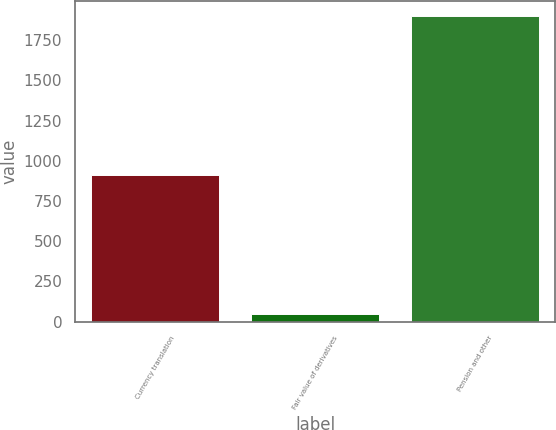Convert chart. <chart><loc_0><loc_0><loc_500><loc_500><bar_chart><fcel>Currency translation<fcel>Fair value of derivatives<fcel>Pension and other<nl><fcel>912<fcel>45<fcel>1901<nl></chart> 